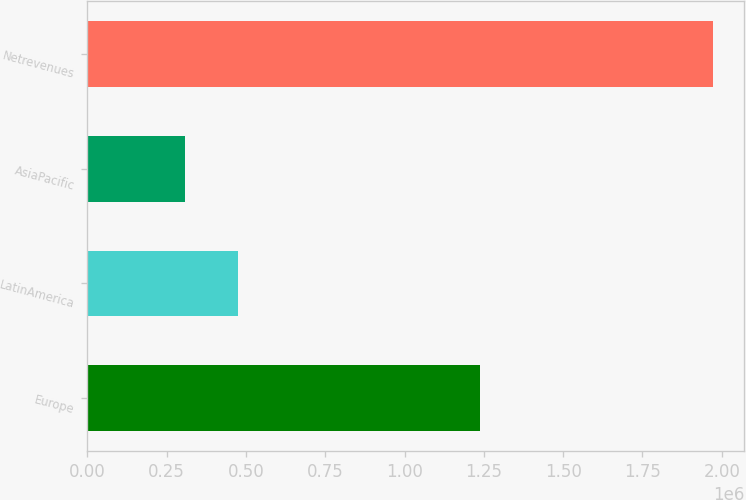Convert chart. <chart><loc_0><loc_0><loc_500><loc_500><bar_chart><fcel>Europe<fcel>LatinAmerica<fcel>AsiaPacific<fcel>Netrevenues<nl><fcel>1.23685e+06<fcel>475216<fcel>308920<fcel>1.97188e+06<nl></chart> 